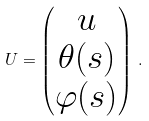Convert formula to latex. <formula><loc_0><loc_0><loc_500><loc_500>U = \begin{pmatrix} u \\ \theta ( s ) \\ \varphi ( s ) \end{pmatrix} \, .</formula> 